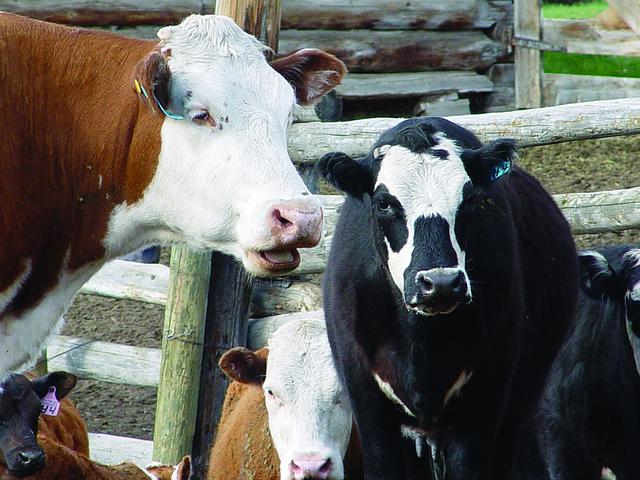What color is the cow?
Be succinct. Black. How many cows have brown markings?
Short answer required. 3. What is the cow doing?
Quick response, please. Mooing. What are the cows doing?
Write a very short answer. Mooing. What is in the brown cow's ear?
Write a very short answer. Tag. Why is the cows two different colors?
Be succinct. Different breeds. 